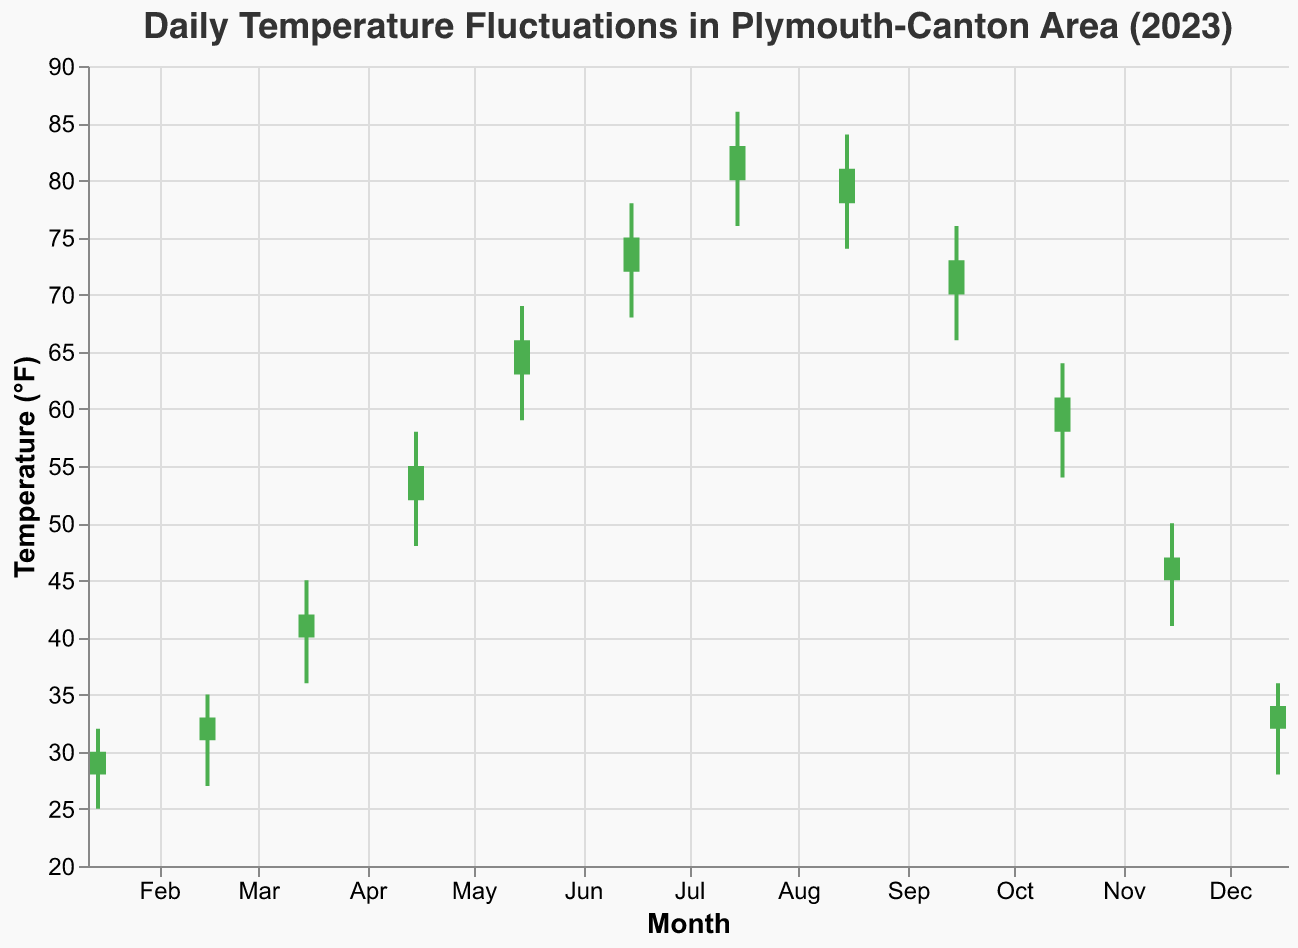What's the title of the plot? The title of the plot is prominently displayed at the top of the chart, indicating what the chart represents.
Answer: Daily Temperature Fluctuations in Plymouth-Canton Area (2023) Which month has the highest daily high temperature? Look for the vertical rule on the chart that reaches the highest value along the y-axis, representing temperature.
Answer: July What's the temperature range for April 15, 2023? The temperature range can be identified as the difference between the highest and lowest values for April 15, 2023, which are represented by the top and bottom of the vertical rule.
Answer: 10°F How many months recorded a closing temperature higher than the opening temperature? Identify the color of the bars. Green bars indicate closing temperatures higher than opening temperatures. Count the number of green bars.
Answer: 11 months During which month did the temperature drop the most from the open to close? Find the bar for each month, calculate the difference between the open and close values, and determine the largest negative difference.
Answer: August In which month is the difference between the high and low temperatures the smallest? Compare the lengths of the vertical rules for each month and find the shortest one.
Answer: February What is the average closing temperature for June and July? Find the closing temperatures for June (75°F) and July (83°F), sum them up, and divide by the number of months. (75 + 83) / 2 = 79
Answer: 79°F Which two consecutive months have the smallest increase in their closing temperatures? Calculate the difference in closing temperatures between consecutive months and find the smallest positive difference.
Answer: July and August How much higher is the high temperature in July compared to January? Subtract the high temperature of January from that of July (86°F - 32°F).
Answer: 54°F Which month experiences the greatest range in daily temperatures? Identify the month with the longest vertical rule, as it represents the greatest range.
Answer: April 